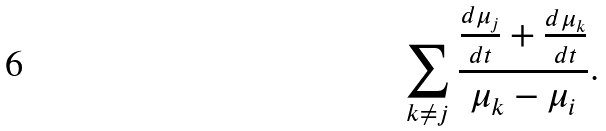Convert formula to latex. <formula><loc_0><loc_0><loc_500><loc_500>\sum _ { k \neq j } \frac { \frac { d \mu _ { j } } { d t } + \frac { d \mu _ { k } } { d t } } { \mu _ { k } - \mu _ { i } } .</formula> 